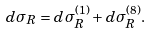Convert formula to latex. <formula><loc_0><loc_0><loc_500><loc_500>d \sigma _ { R } = d \sigma _ { R } ^ { ( 1 ) } + d \sigma _ { R } ^ { ( 8 ) } .</formula> 